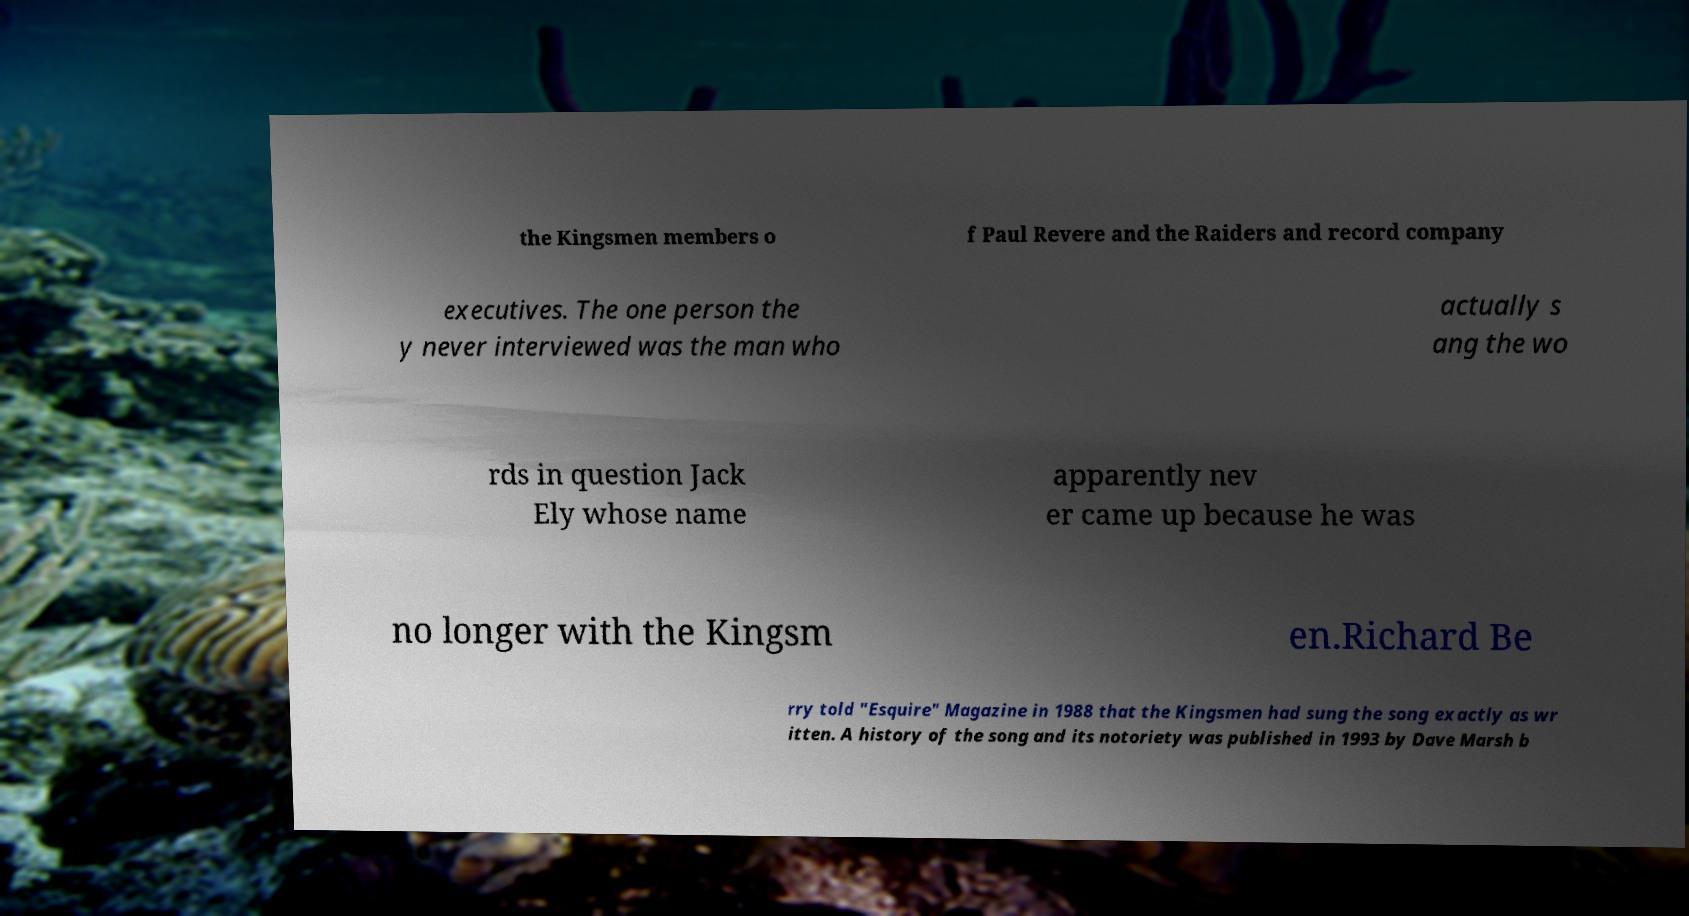For documentation purposes, I need the text within this image transcribed. Could you provide that? the Kingsmen members o f Paul Revere and the Raiders and record company executives. The one person the y never interviewed was the man who actually s ang the wo rds in question Jack Ely whose name apparently nev er came up because he was no longer with the Kingsm en.Richard Be rry told "Esquire" Magazine in 1988 that the Kingsmen had sung the song exactly as wr itten. A history of the song and its notoriety was published in 1993 by Dave Marsh b 